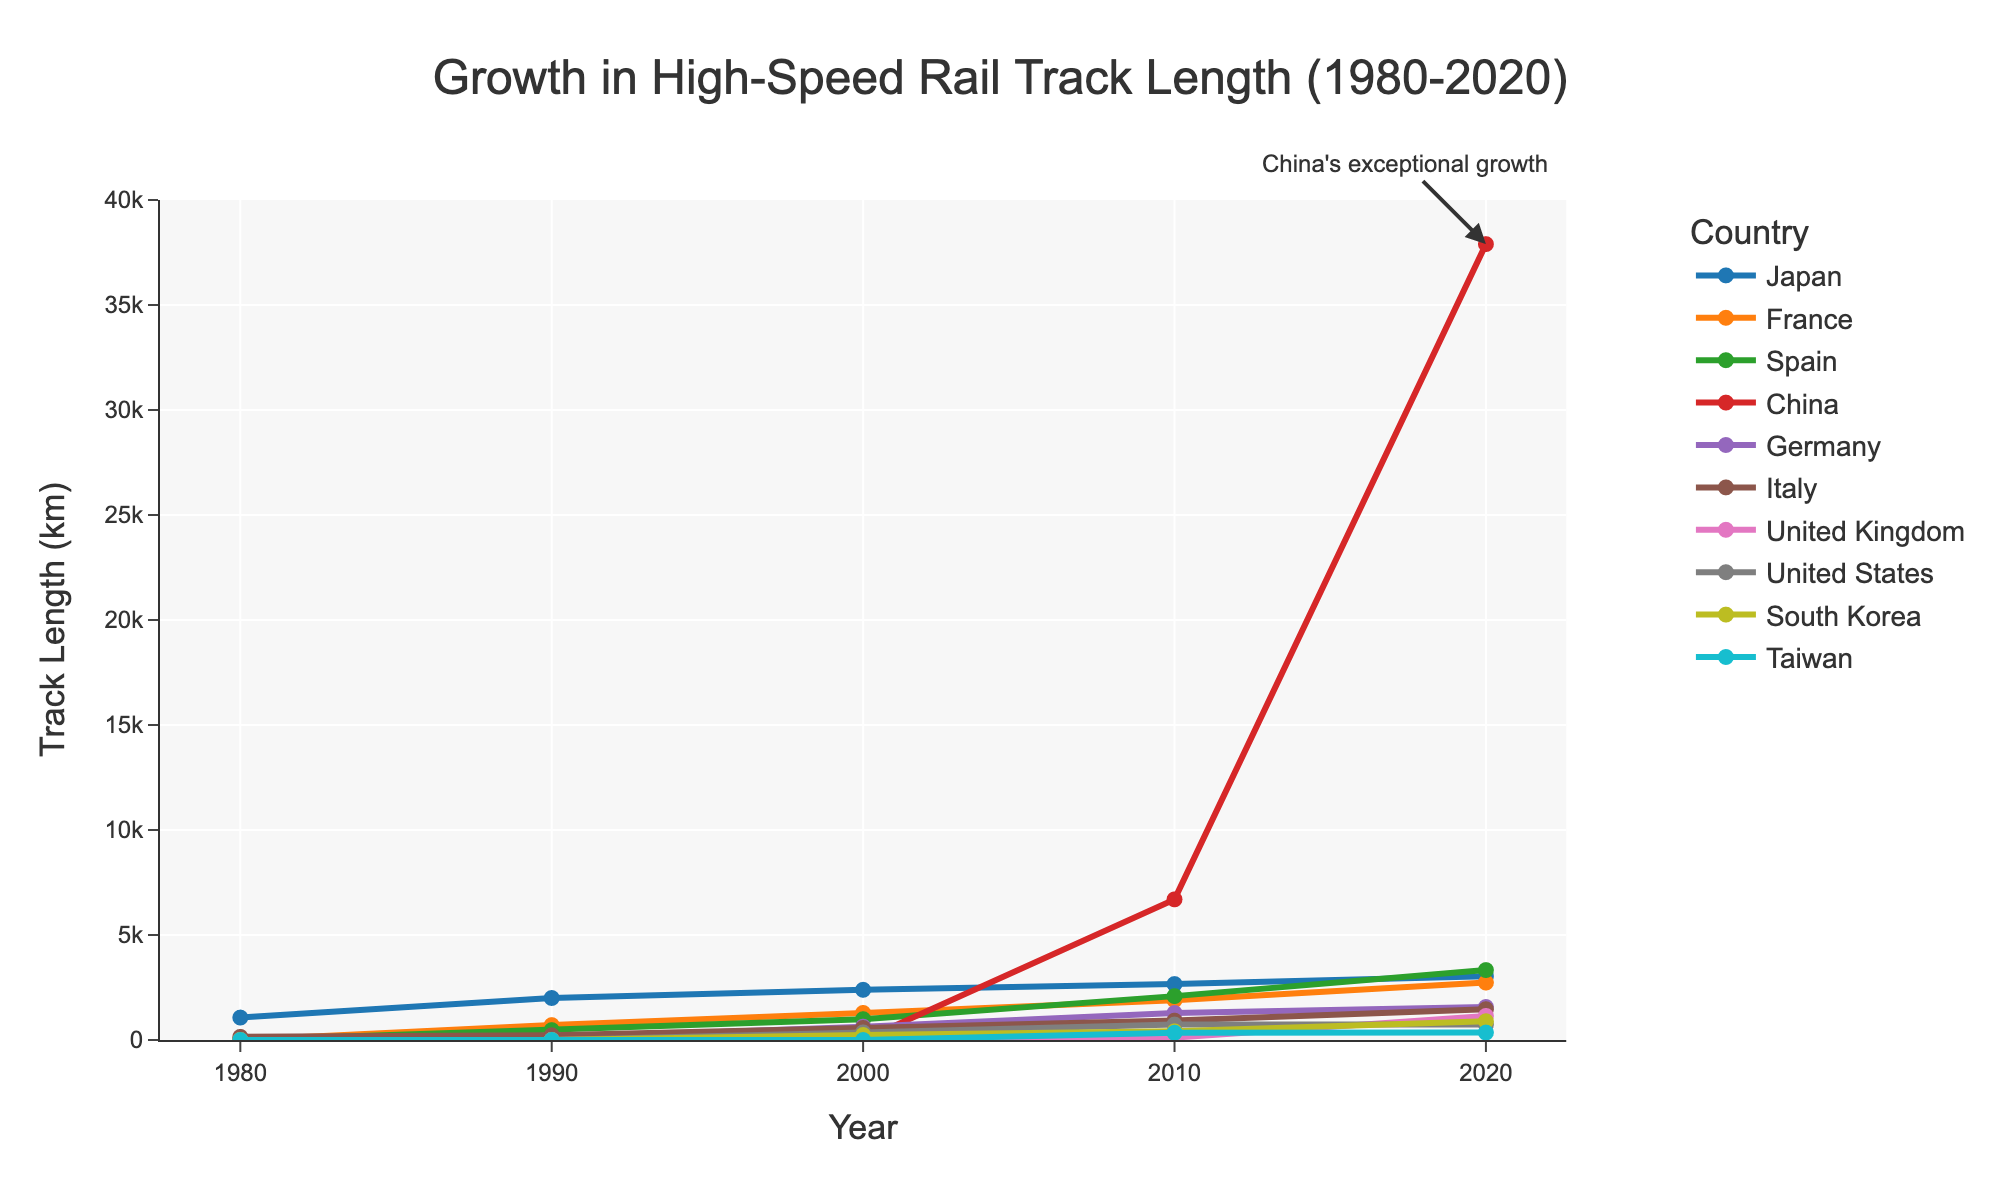Which country showed the steepest increase in high-speed rail track length after 2000? By observing the year-by-year increments, China exhibits a sharp rise starting from 2000, reaching 37,900 km by 2020. Other countries show more gradual increases.
Answer: China Compare the high-speed rail lengths of Japan and France in 1990. Which country had more? Checking the values in 1990, Japan had 2,000 km while France had 710 km.
Answer: Japan How much high-speed rail track was added in Spain between 2010 and 2020? The track length in Spain was 2,090 km in 2010 and increased to 3,330 km in 2020. The difference is 3,330 - 2,090 = 1,240 km.
Answer: 1,240 km Which countries had zero high-speed rail track lengths in 1980? Observing the figure, France, Spain, China, Germany, the UK, the US, South Korea, and Taiwan all had zero lengths in 1980. Japan and Italy were the only countries with high-speed rail tracks in 1980.
Answer: France, Spain, China, Germany, UK, US, South Korea, Taiwan What is the average high-speed rail track length of Germany across all the provided years? Calculating the average of Germany's track lengths: (0 + 90 + 636 + 1,285 + 1,571) / 5 = 3,582 / 5.
Answer: 716.4 km Which country had the least growth in high-speed rail track length between 1980 and 2020? By observing the differences from 1980 to 2020 for all countries, the United States only increased from 0 to 735 km, the smallest increase.
Answer: United States Identify the year when China surpassed Japan in high-speed rail track length. In 2010, China had 6,696 km while Japan had 2,664 km. In previous years, China had no high-speed rail tracks.
Answer: 2010 What is the difference in high-speed rail track length between the United Kingdom and South Korea in 2020? In 2020, the UK had 1,147 km and South Korea had 893 km. The difference is 1,147 - 893 = 254 km.
Answer: 254 km Which countries exceeded 2,000 km of high-speed rail tracks in 2010? In 2010, Spain (2,090 km) and China (6,696 km) exceeded 2,000 km.
Answer: Spain, China Compare the high-speed rail growth trends of Japan and China between 2000 and 2020. China shows an exponential increase from 0 km in 2000 to 37,900 km by 2020, while Japan shows a gradual increase from 2,390 km to 3,041 km over the same period.
Answer: China's growth is exponential, Japan's is gradual 